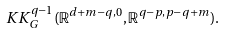Convert formula to latex. <formula><loc_0><loc_0><loc_500><loc_500>K K _ { G } ^ { q - 1 } ( \mathbb { R } ^ { d + m - q , 0 } , \mathbb { R } ^ { q - p , p - q + m } ) .</formula> 